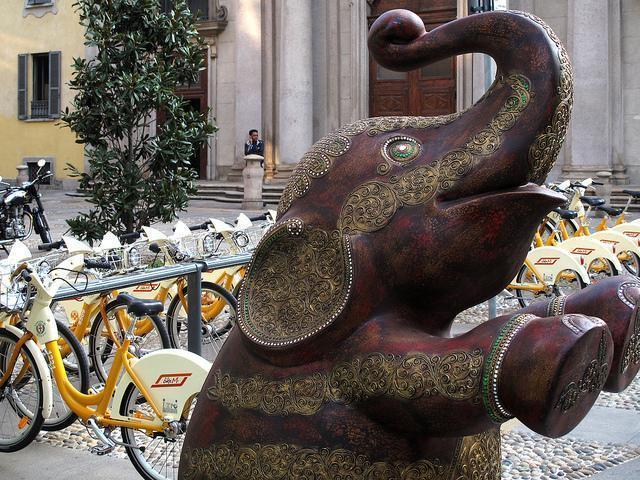Why are all the bikes the same?
Choose the correct response and explain in the format: 'Answer: answer
Rationale: rationale.'
Options: Family owned, rentals, trends, government issued. Answer: rentals.
Rationale: The bikes are rentals. The statue best represents who?
Choose the right answer from the provided options to respond to the question.
Options: Thor, ganesh, hades, anubis. Ganesh. 